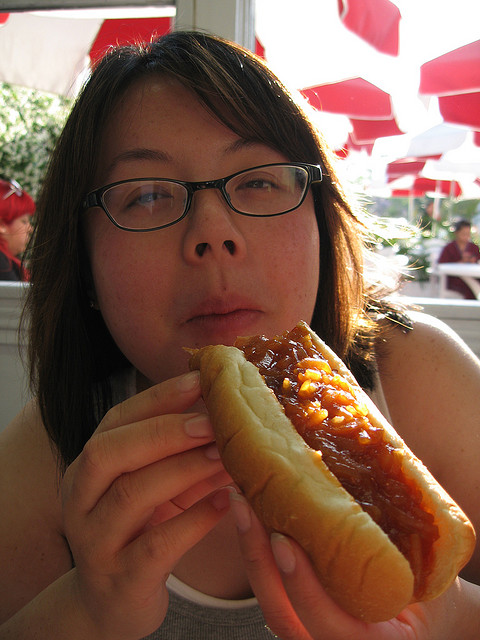Are there any distinctive accessories the person is wearing? Yes, the person is wearing eyeglasses with a dark frame, which are the most noticeable accessory. 